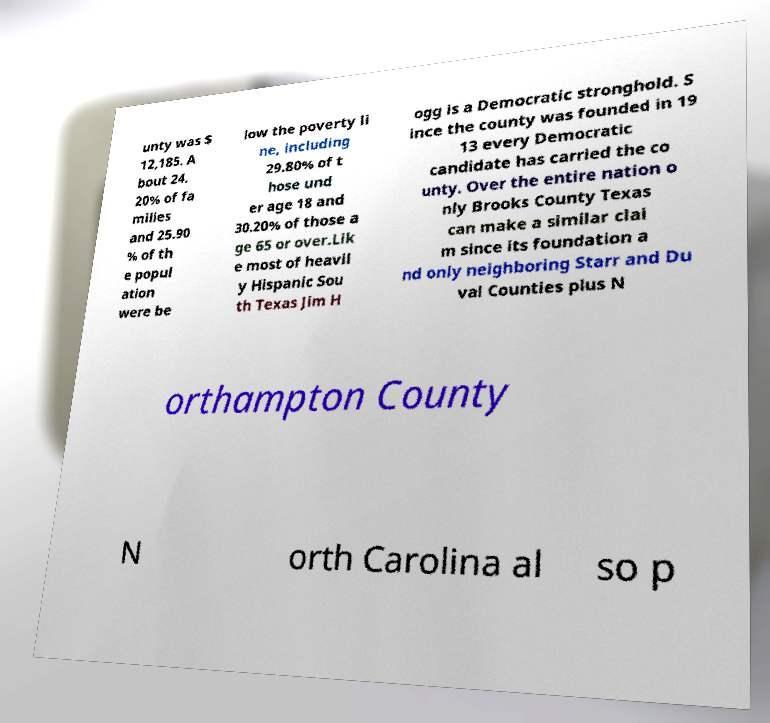For documentation purposes, I need the text within this image transcribed. Could you provide that? unty was $ 12,185. A bout 24. 20% of fa milies and 25.90 % of th e popul ation were be low the poverty li ne, including 29.80% of t hose und er age 18 and 30.20% of those a ge 65 or over.Lik e most of heavil y Hispanic Sou th Texas Jim H ogg is a Democratic stronghold. S ince the county was founded in 19 13 every Democratic candidate has carried the co unty. Over the entire nation o nly Brooks County Texas can make a similar clai m since its foundation a nd only neighboring Starr and Du val Counties plus N orthampton County N orth Carolina al so p 